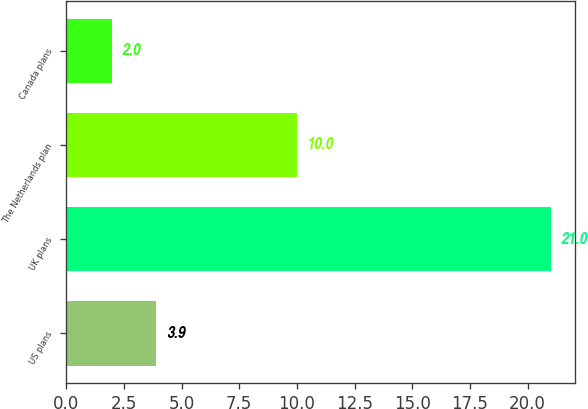Convert chart to OTSL. <chart><loc_0><loc_0><loc_500><loc_500><bar_chart><fcel>US plans<fcel>UK plans<fcel>The Netherlands plan<fcel>Canada plans<nl><fcel>3.9<fcel>21<fcel>10<fcel>2<nl></chart> 